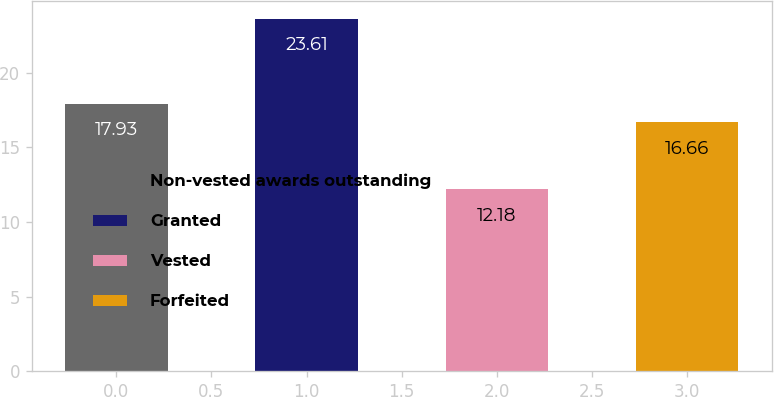Convert chart. <chart><loc_0><loc_0><loc_500><loc_500><bar_chart><fcel>Non-vested awards outstanding<fcel>Granted<fcel>Vested<fcel>Forfeited<nl><fcel>17.93<fcel>23.61<fcel>12.18<fcel>16.66<nl></chart> 